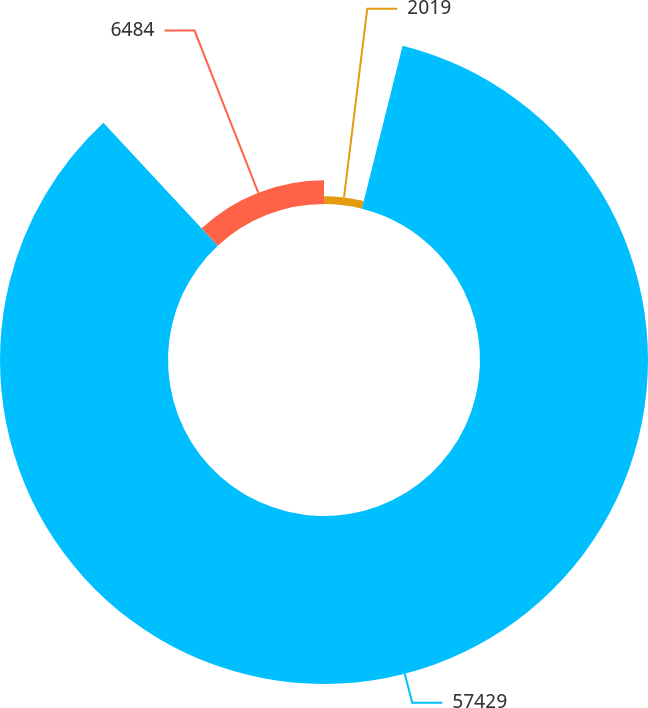Convert chart. <chart><loc_0><loc_0><loc_500><loc_500><pie_chart><fcel>2019<fcel>57429<fcel>6484<nl><fcel>3.9%<fcel>84.18%<fcel>11.92%<nl></chart> 